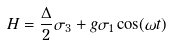Convert formula to latex. <formula><loc_0><loc_0><loc_500><loc_500>H = \frac { \Delta } { 2 } \sigma _ { 3 } + g \sigma _ { 1 } \cos ( \omega t )</formula> 